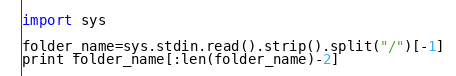<code> <loc_0><loc_0><loc_500><loc_500><_Python_>import sys

folder_name=sys.stdin.read().strip().split("/")[-1]
print folder_name[:len(folder_name)-2]
</code> 